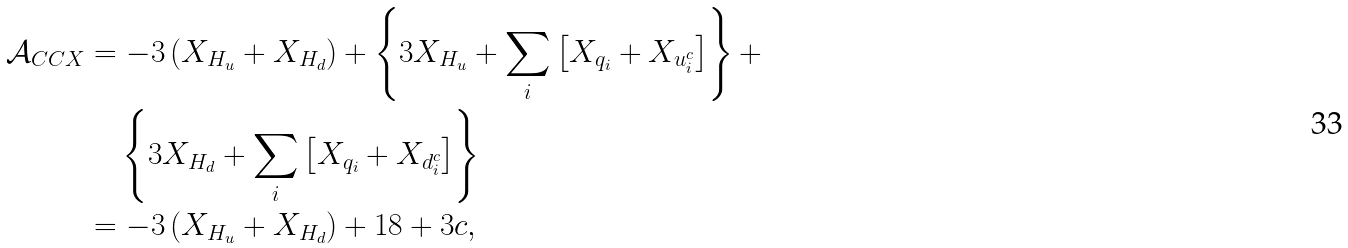<formula> <loc_0><loc_0><loc_500><loc_500>\mathcal { A } _ { C C X } & = - 3 \left ( X _ { H _ { u } } + X _ { H _ { d } } \right ) + \left \{ 3 X _ { H _ { u } } + \sum _ { i } \left [ X _ { q _ { i } } + X _ { u ^ { c } _ { i } } \right ] \right \} + \\ & \quad \left \{ 3 X _ { H _ { d } } + \sum _ { i } \left [ X _ { q _ { i } } + X _ { d ^ { c } _ { i } } \right ] \right \} \\ & = - 3 \left ( X _ { H _ { u } } + X _ { H _ { d } } \right ) + 1 8 + 3 c , \,</formula> 